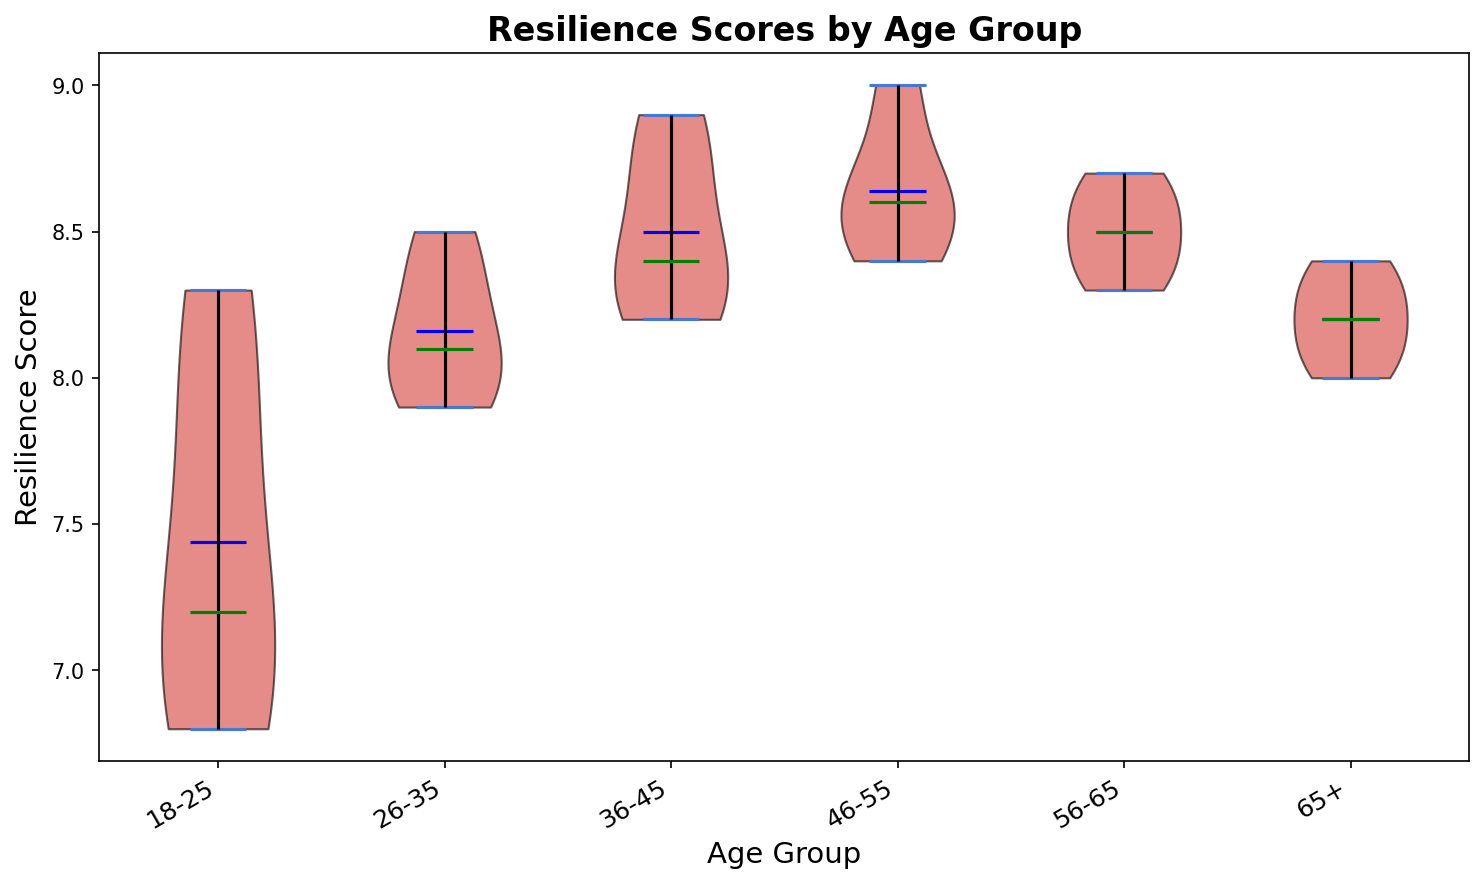Which age group has the highest mean resilience score? Observing the violin plot, the horizontal blue lines represent the mean resilience scores. The 46-55 age group has the highest blue line.
Answer: 46-55 What is the median resilience score for the 18-25 age group? The green line inside the violin plot for the 18-25 age group represents the median. For this group, the median is shown at approximately 7.9.
Answer: 7.9 How does the spread (range) of resilience scores compare between the 18-25 and 46-55 age groups? The spread is visualized by the width of the violin plots. The 18-25 group shows a wider spread, indicating more variability, whereas the 46-55 group shows a narrower, more concentrated spread.
Answer: The 18-25 group has a wider spread Which age group has the smallest median resilience score? By examining the green lines for medians in each violin box, the 65+ age group has the lowest green line among all groups.
Answer: 65+ What are the mean and median resilience scores for the 36-45 age group? The mean is indicated by the blue line and the median by the green line within the violin plot for the 36-45 age group. The blue line is at approximately 8.5, and the green line is at approximately 8.4.
Answer: Mean: 8.5, Median: 8.4 Which age group shows the greatest range of resilience scores? The range is observed by the vertical extent of the violin plot. The 18-25 age group has the tallest violin body, indicating the largest range.
Answer: 18-25 For the age group 56-65, what is the approximate mean resilience score, and how does it compare to the median? The mean is indicated by the blue line and the median by the green line in the 56-65 age group's violin plot. Both lines are very close, with the mean being around 8.5 and the median slightly lower but very close to 8.5.
Answer: Mean: 8.5, Median: Close to 8.5 Which age group has the least variability in resilience scores? The tightest (narrowest) violin plot indicates the least variability, which is evident for the 65+ age group.
Answer: 65+ How do the median resilience scores for 26-35 and 46-55 age groups compare? Comparing the green lines (medians) of these two groups, both are very close; however, the 46-55 group is slightly higher than the 26-35 group.
Answer: The 46-55 group is slightly higher In which age group do the mean and median resilience scores differ the most? The difference between the blue line (mean) and green line (median) can be observed for each group. The 18-25 group shows the most noticeable gap between these lines.
Answer: 18-25 